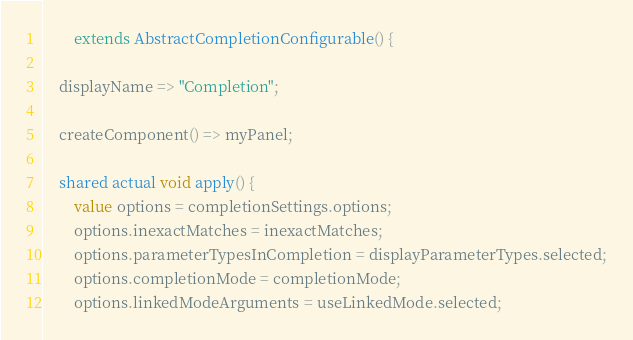<code> <loc_0><loc_0><loc_500><loc_500><_Ceylon_>        extends AbstractCompletionConfigurable() {

    displayName => "Completion";

    createComponent() => myPanel;

    shared actual void apply() {
        value options = completionSettings.options;
        options.inexactMatches = inexactMatches;
        options.parameterTypesInCompletion = displayParameterTypes.selected;
        options.completionMode = completionMode;
        options.linkedModeArguments = useLinkedMode.selected;</code> 